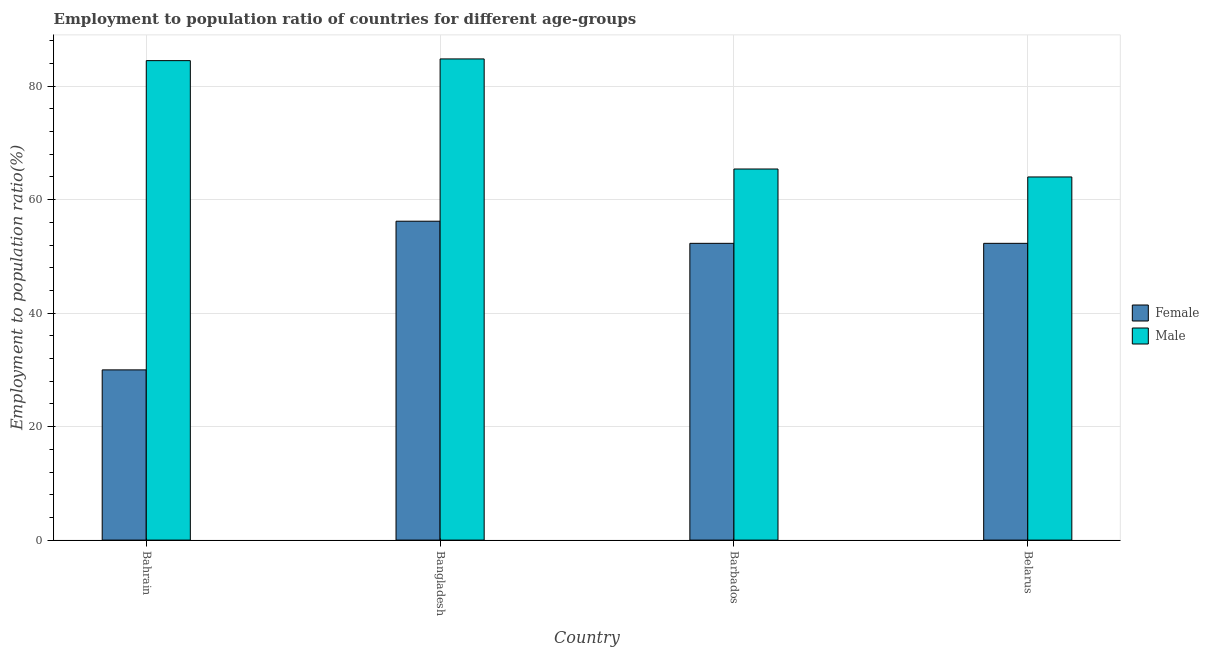How many groups of bars are there?
Give a very brief answer. 4. Are the number of bars per tick equal to the number of legend labels?
Your answer should be compact. Yes. How many bars are there on the 2nd tick from the left?
Your response must be concise. 2. How many bars are there on the 1st tick from the right?
Give a very brief answer. 2. What is the label of the 3rd group of bars from the left?
Your answer should be very brief. Barbados. In how many cases, is the number of bars for a given country not equal to the number of legend labels?
Your answer should be compact. 0. What is the employment to population ratio(female) in Bangladesh?
Offer a very short reply. 56.2. Across all countries, what is the maximum employment to population ratio(male)?
Provide a succinct answer. 84.8. Across all countries, what is the minimum employment to population ratio(male)?
Your answer should be compact. 64. In which country was the employment to population ratio(male) minimum?
Provide a short and direct response. Belarus. What is the total employment to population ratio(female) in the graph?
Offer a very short reply. 190.8. What is the difference between the employment to population ratio(female) in Bangladesh and that in Belarus?
Offer a terse response. 3.9. What is the difference between the employment to population ratio(female) in Bahrain and the employment to population ratio(male) in Belarus?
Offer a terse response. -34. What is the average employment to population ratio(male) per country?
Give a very brief answer. 74.68. What is the difference between the employment to population ratio(female) and employment to population ratio(male) in Belarus?
Keep it short and to the point. -11.7. In how many countries, is the employment to population ratio(male) greater than 52 %?
Make the answer very short. 4. What is the ratio of the employment to population ratio(male) in Barbados to that in Belarus?
Make the answer very short. 1.02. Is the employment to population ratio(female) in Bangladesh less than that in Belarus?
Ensure brevity in your answer.  No. What is the difference between the highest and the second highest employment to population ratio(female)?
Your answer should be compact. 3.9. What is the difference between the highest and the lowest employment to population ratio(female)?
Ensure brevity in your answer.  26.2. In how many countries, is the employment to population ratio(male) greater than the average employment to population ratio(male) taken over all countries?
Your answer should be compact. 2. Is the sum of the employment to population ratio(female) in Barbados and Belarus greater than the maximum employment to population ratio(male) across all countries?
Offer a very short reply. Yes. What does the 1st bar from the left in Bangladesh represents?
Give a very brief answer. Female. What does the 2nd bar from the right in Bahrain represents?
Give a very brief answer. Female. How many bars are there?
Keep it short and to the point. 8. Are all the bars in the graph horizontal?
Ensure brevity in your answer.  No. Does the graph contain grids?
Provide a succinct answer. Yes. How many legend labels are there?
Ensure brevity in your answer.  2. What is the title of the graph?
Ensure brevity in your answer.  Employment to population ratio of countries for different age-groups. What is the label or title of the X-axis?
Offer a terse response. Country. What is the Employment to population ratio(%) of Male in Bahrain?
Your response must be concise. 84.5. What is the Employment to population ratio(%) in Female in Bangladesh?
Your answer should be very brief. 56.2. What is the Employment to population ratio(%) in Male in Bangladesh?
Offer a terse response. 84.8. What is the Employment to population ratio(%) of Female in Barbados?
Provide a short and direct response. 52.3. What is the Employment to population ratio(%) of Male in Barbados?
Your answer should be very brief. 65.4. What is the Employment to population ratio(%) of Female in Belarus?
Your answer should be very brief. 52.3. What is the Employment to population ratio(%) in Male in Belarus?
Your response must be concise. 64. Across all countries, what is the maximum Employment to population ratio(%) in Female?
Your answer should be very brief. 56.2. Across all countries, what is the maximum Employment to population ratio(%) of Male?
Your answer should be compact. 84.8. What is the total Employment to population ratio(%) of Female in the graph?
Make the answer very short. 190.8. What is the total Employment to population ratio(%) of Male in the graph?
Ensure brevity in your answer.  298.7. What is the difference between the Employment to population ratio(%) of Female in Bahrain and that in Bangladesh?
Make the answer very short. -26.2. What is the difference between the Employment to population ratio(%) in Female in Bahrain and that in Barbados?
Your answer should be compact. -22.3. What is the difference between the Employment to population ratio(%) of Female in Bahrain and that in Belarus?
Make the answer very short. -22.3. What is the difference between the Employment to population ratio(%) of Male in Bangladesh and that in Belarus?
Offer a very short reply. 20.8. What is the difference between the Employment to population ratio(%) in Female in Barbados and that in Belarus?
Offer a very short reply. 0. What is the difference between the Employment to population ratio(%) in Male in Barbados and that in Belarus?
Offer a terse response. 1.4. What is the difference between the Employment to population ratio(%) in Female in Bahrain and the Employment to population ratio(%) in Male in Bangladesh?
Offer a terse response. -54.8. What is the difference between the Employment to population ratio(%) in Female in Bahrain and the Employment to population ratio(%) in Male in Barbados?
Your answer should be compact. -35.4. What is the difference between the Employment to population ratio(%) in Female in Bahrain and the Employment to population ratio(%) in Male in Belarus?
Your answer should be very brief. -34. What is the difference between the Employment to population ratio(%) of Female in Barbados and the Employment to population ratio(%) of Male in Belarus?
Your answer should be very brief. -11.7. What is the average Employment to population ratio(%) of Female per country?
Provide a succinct answer. 47.7. What is the average Employment to population ratio(%) in Male per country?
Give a very brief answer. 74.67. What is the difference between the Employment to population ratio(%) of Female and Employment to population ratio(%) of Male in Bahrain?
Your answer should be compact. -54.5. What is the difference between the Employment to population ratio(%) in Female and Employment to population ratio(%) in Male in Bangladesh?
Make the answer very short. -28.6. What is the difference between the Employment to population ratio(%) in Female and Employment to population ratio(%) in Male in Belarus?
Ensure brevity in your answer.  -11.7. What is the ratio of the Employment to population ratio(%) in Female in Bahrain to that in Bangladesh?
Provide a short and direct response. 0.53. What is the ratio of the Employment to population ratio(%) of Female in Bahrain to that in Barbados?
Offer a terse response. 0.57. What is the ratio of the Employment to population ratio(%) in Male in Bahrain to that in Barbados?
Offer a terse response. 1.29. What is the ratio of the Employment to population ratio(%) of Female in Bahrain to that in Belarus?
Your answer should be compact. 0.57. What is the ratio of the Employment to population ratio(%) of Male in Bahrain to that in Belarus?
Your answer should be very brief. 1.32. What is the ratio of the Employment to population ratio(%) of Female in Bangladesh to that in Barbados?
Offer a very short reply. 1.07. What is the ratio of the Employment to population ratio(%) in Male in Bangladesh to that in Barbados?
Your answer should be very brief. 1.3. What is the ratio of the Employment to population ratio(%) in Female in Bangladesh to that in Belarus?
Your response must be concise. 1.07. What is the ratio of the Employment to population ratio(%) of Male in Bangladesh to that in Belarus?
Provide a short and direct response. 1.32. What is the ratio of the Employment to population ratio(%) in Male in Barbados to that in Belarus?
Provide a short and direct response. 1.02. What is the difference between the highest and the lowest Employment to population ratio(%) of Female?
Provide a succinct answer. 26.2. What is the difference between the highest and the lowest Employment to population ratio(%) of Male?
Make the answer very short. 20.8. 